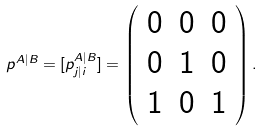<formula> <loc_0><loc_0><loc_500><loc_500>p ^ { A | B } = [ p ^ { A | B } _ { j | i } ] = \left ( \begin{array} { c c c } 0 & 0 & 0 \\ 0 & 1 & 0 \\ 1 & 0 & 1 \end{array} \right ) .</formula> 